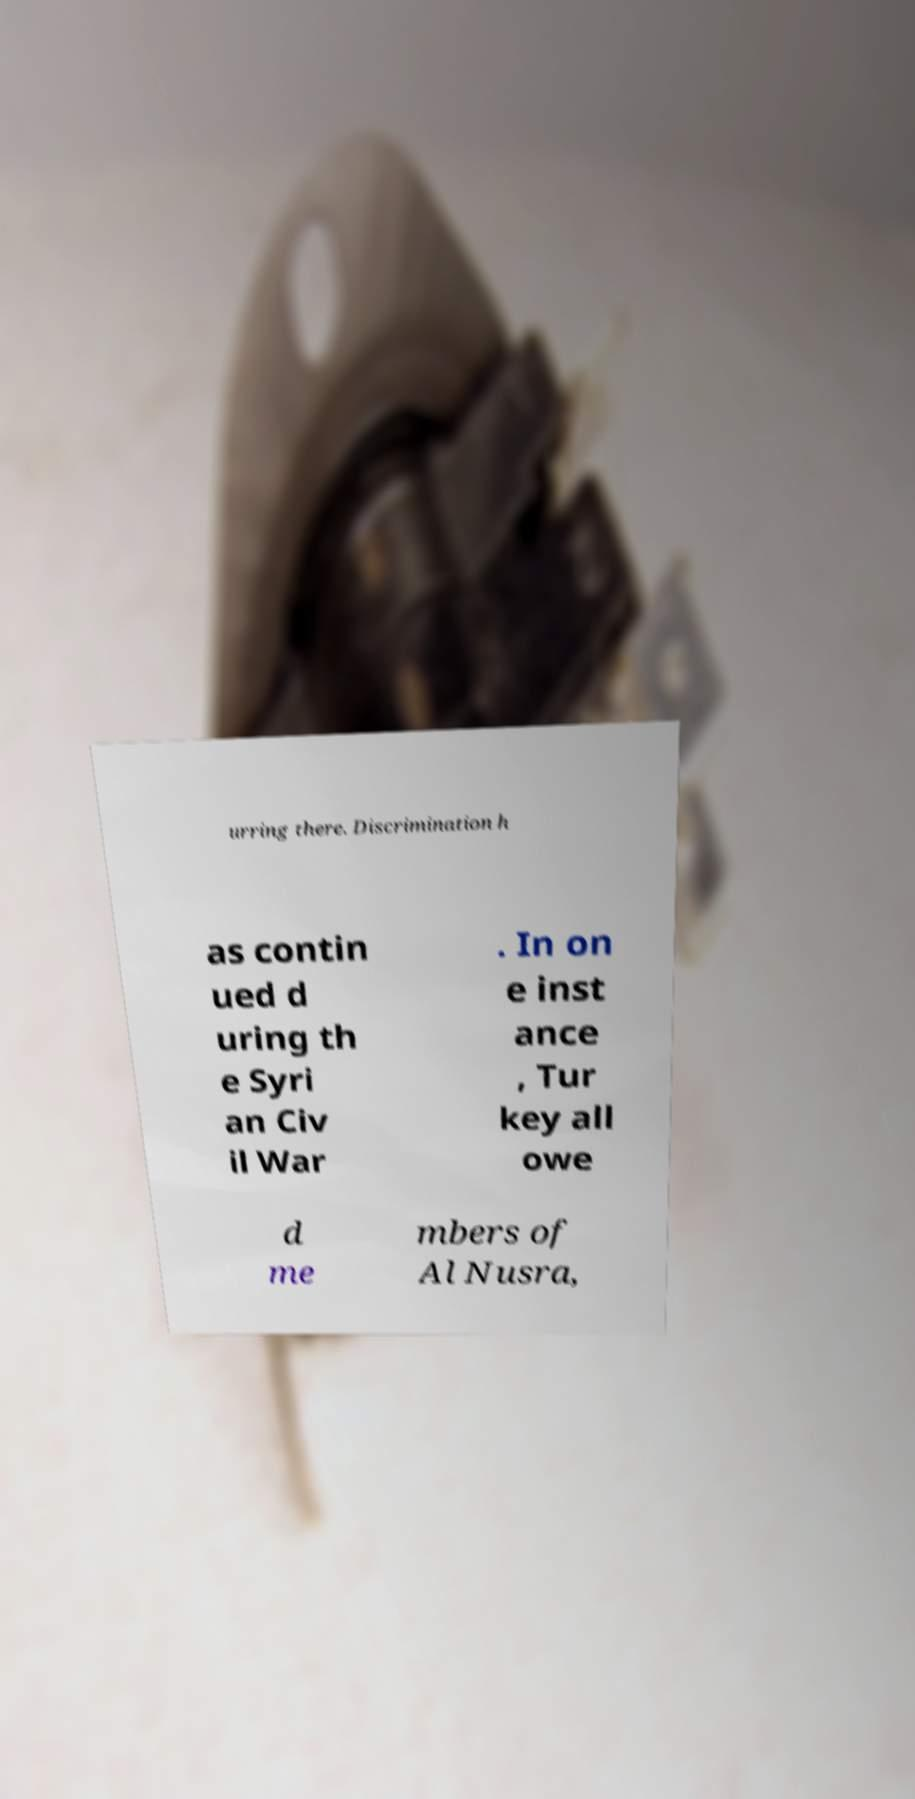Could you extract and type out the text from this image? urring there. Discrimination h as contin ued d uring th e Syri an Civ il War . In on e inst ance , Tur key all owe d me mbers of Al Nusra, 